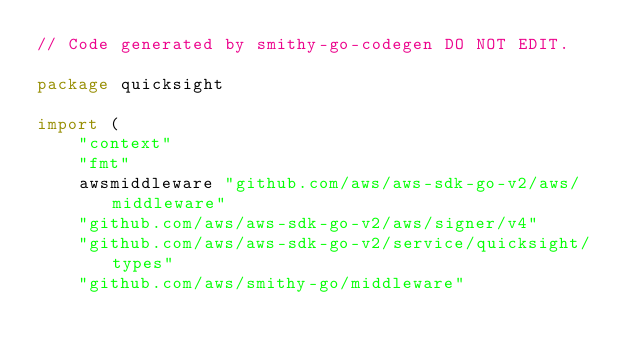<code> <loc_0><loc_0><loc_500><loc_500><_Go_>// Code generated by smithy-go-codegen DO NOT EDIT.

package quicksight

import (
	"context"
	"fmt"
	awsmiddleware "github.com/aws/aws-sdk-go-v2/aws/middleware"
	"github.com/aws/aws-sdk-go-v2/aws/signer/v4"
	"github.com/aws/aws-sdk-go-v2/service/quicksight/types"
	"github.com/aws/smithy-go/middleware"</code> 